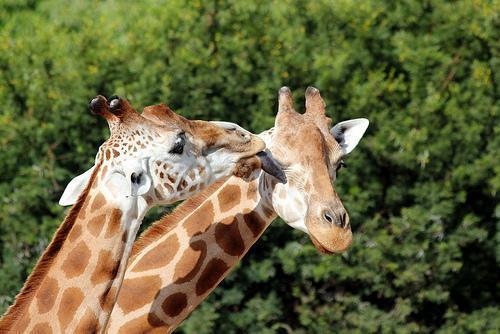How many giraffes are there?
Give a very brief answer. 2. 